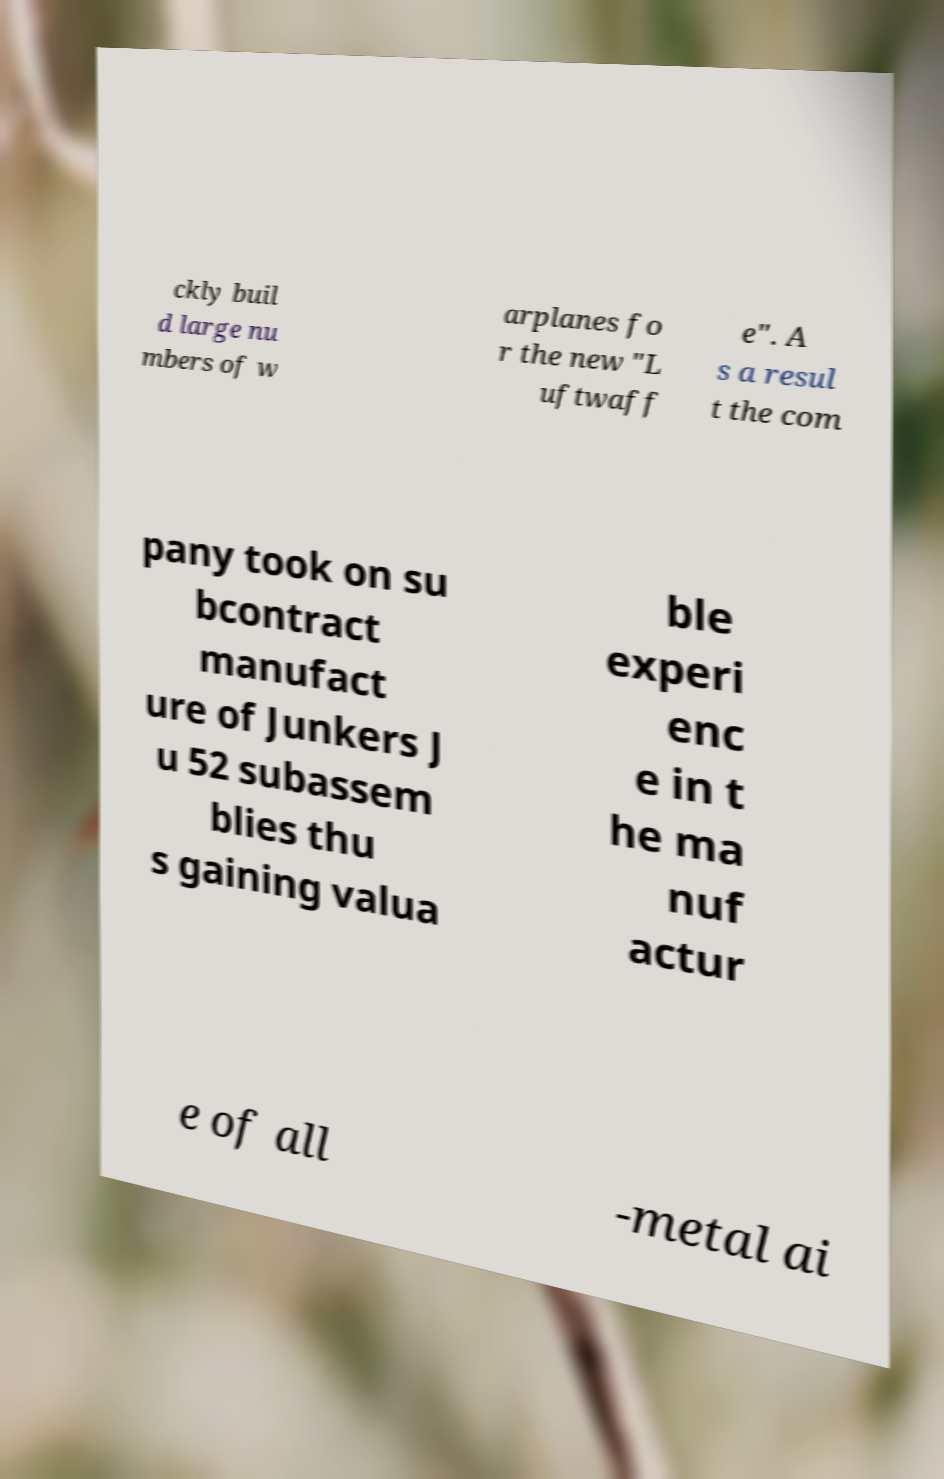Could you extract and type out the text from this image? ckly buil d large nu mbers of w arplanes fo r the new "L uftwaff e". A s a resul t the com pany took on su bcontract manufact ure of Junkers J u 52 subassem blies thu s gaining valua ble experi enc e in t he ma nuf actur e of all -metal ai 